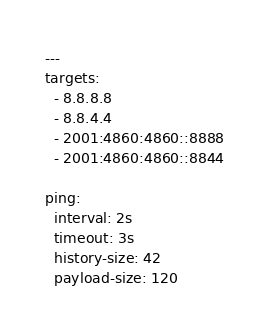Convert code to text. <code><loc_0><loc_0><loc_500><loc_500><_YAML_>---
targets:
  - 8.8.8.8
  - 8.8.4.4
  - 2001:4860:4860::8888
  - 2001:4860:4860::8844

ping:
  interval: 2s
  timeout: 3s
  history-size: 42
  payload-size: 120
</code> 